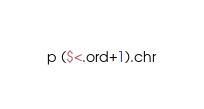<code> <loc_0><loc_0><loc_500><loc_500><_Ruby_>p ($<.ord+1).chr</code> 